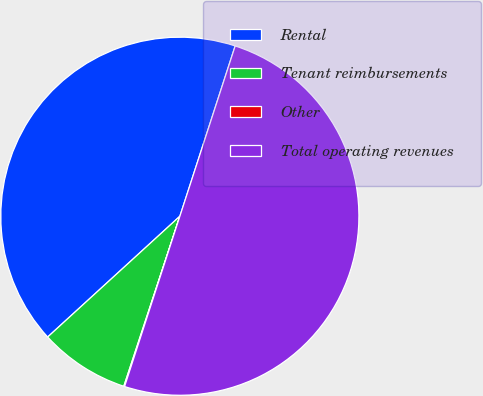Convert chart to OTSL. <chart><loc_0><loc_0><loc_500><loc_500><pie_chart><fcel>Rental<fcel>Tenant reimbursements<fcel>Other<fcel>Total operating revenues<nl><fcel>41.78%<fcel>8.15%<fcel>0.07%<fcel>50.0%<nl></chart> 